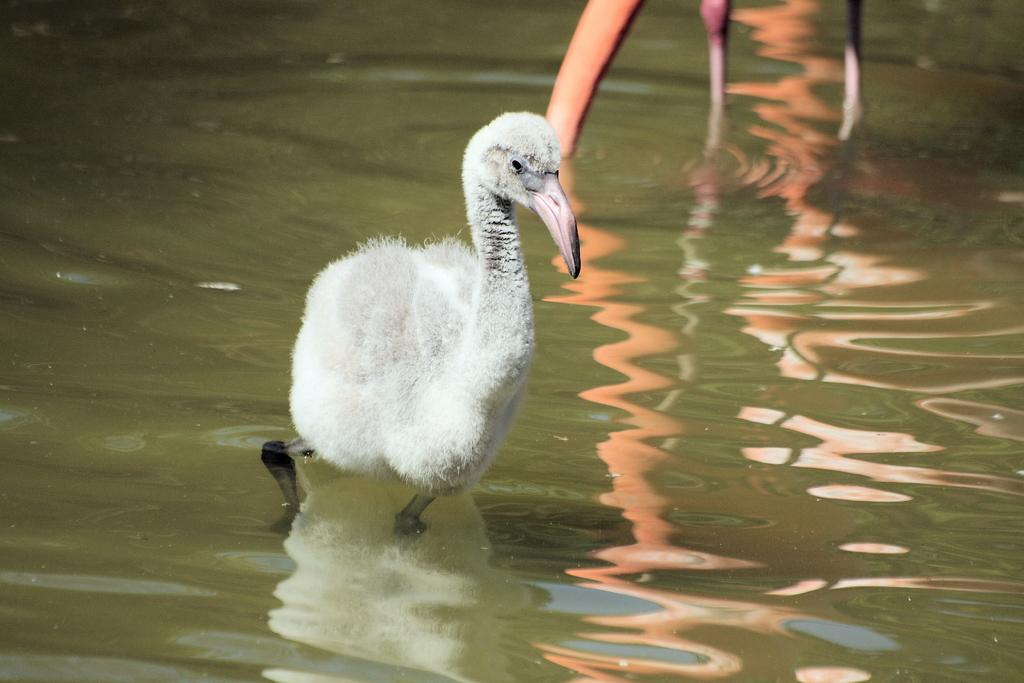What is visible in the image? There is water visible in the image, along with a white-colored bird in the center and another bird on the top. Can you describe the white-colored bird in the image? The white-colored bird is in the center of the image. How many birds are visible in the image? There are two birds visible in the image. What type of iron can be seen in the image? There is no iron present in the image. What color is the patch on the bird's tail in the image? There is no patch or tail mentioned in the image, as it only describes a white-colored bird and another bird on the top. 